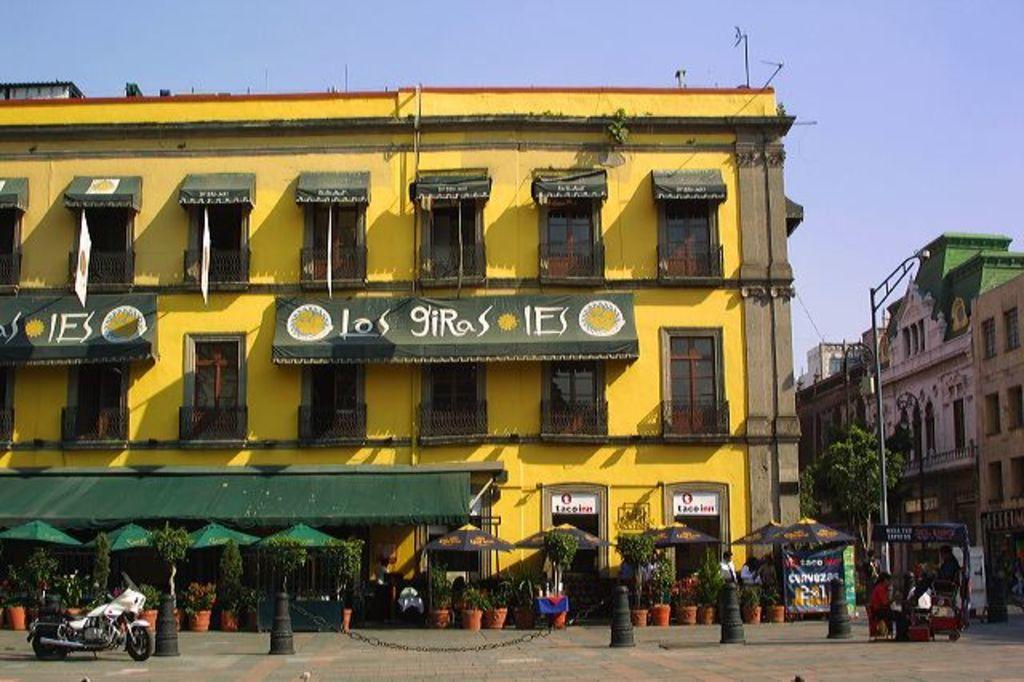Please provide a concise description of this image. In this image there are buildings, in front of the building there are trees, plant pots and few people are standing and there is a bike parked, beside the bike there are safety cones. On the right side of the image there is a camp and few persons are standing. In the background there is a sky. 